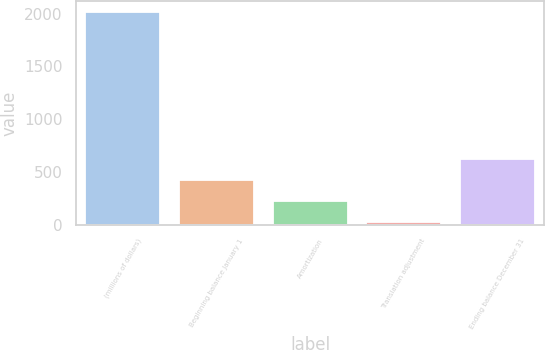<chart> <loc_0><loc_0><loc_500><loc_500><bar_chart><fcel>(millions of dollars)<fcel>Beginning balance January 1<fcel>Amortization<fcel>Translation adjustment<fcel>Ending balance December 31<nl><fcel>2017<fcel>421.48<fcel>222.04<fcel>22.6<fcel>620.92<nl></chart> 